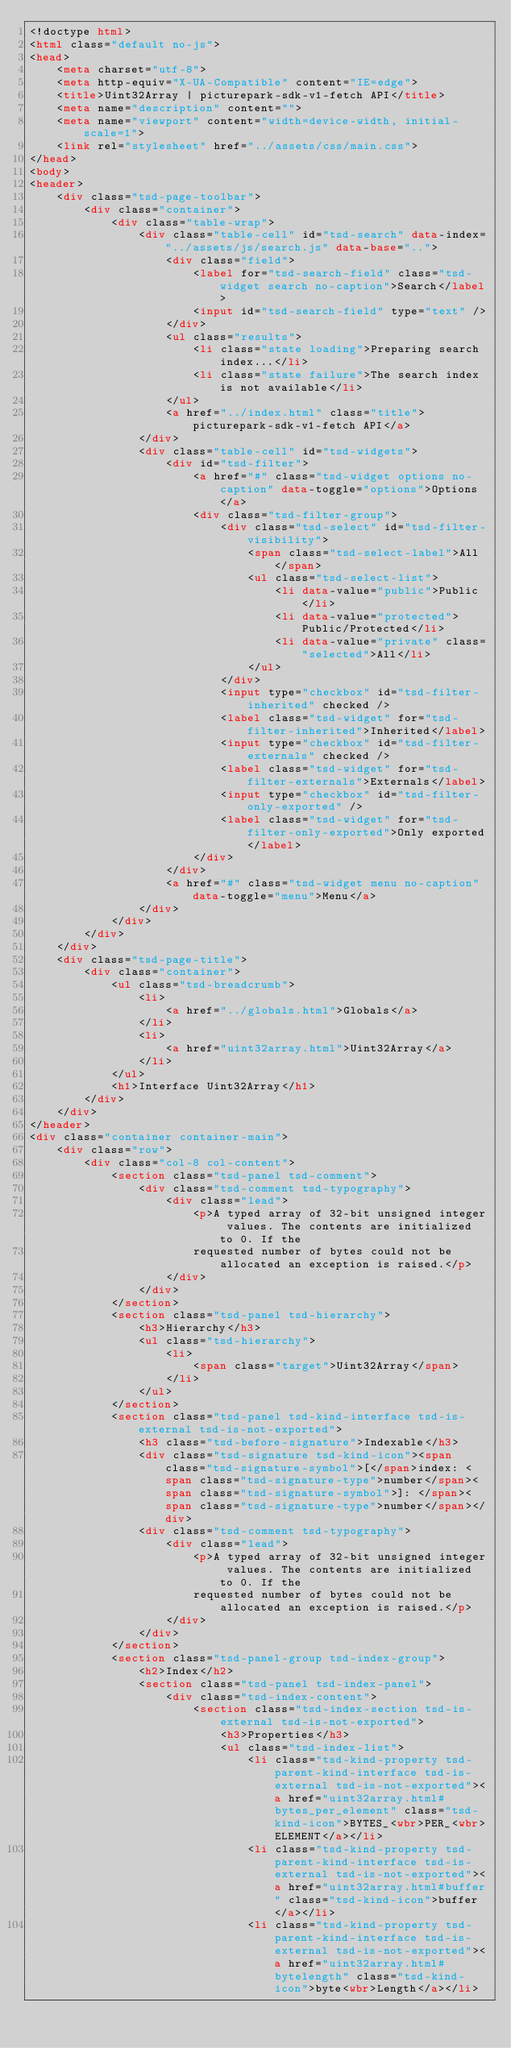Convert code to text. <code><loc_0><loc_0><loc_500><loc_500><_HTML_><!doctype html>
<html class="default no-js">
<head>
	<meta charset="utf-8">
	<meta http-equiv="X-UA-Compatible" content="IE=edge">
	<title>Uint32Array | picturepark-sdk-v1-fetch API</title>
	<meta name="description" content="">
	<meta name="viewport" content="width=device-width, initial-scale=1">
	<link rel="stylesheet" href="../assets/css/main.css">
</head>
<body>
<header>
	<div class="tsd-page-toolbar">
		<div class="container">
			<div class="table-wrap">
				<div class="table-cell" id="tsd-search" data-index="../assets/js/search.js" data-base="..">
					<div class="field">
						<label for="tsd-search-field" class="tsd-widget search no-caption">Search</label>
						<input id="tsd-search-field" type="text" />
					</div>
					<ul class="results">
						<li class="state loading">Preparing search index...</li>
						<li class="state failure">The search index is not available</li>
					</ul>
					<a href="../index.html" class="title">picturepark-sdk-v1-fetch API</a>
				</div>
				<div class="table-cell" id="tsd-widgets">
					<div id="tsd-filter">
						<a href="#" class="tsd-widget options no-caption" data-toggle="options">Options</a>
						<div class="tsd-filter-group">
							<div class="tsd-select" id="tsd-filter-visibility">
								<span class="tsd-select-label">All</span>
								<ul class="tsd-select-list">
									<li data-value="public">Public</li>
									<li data-value="protected">Public/Protected</li>
									<li data-value="private" class="selected">All</li>
								</ul>
							</div>
							<input type="checkbox" id="tsd-filter-inherited" checked />
							<label class="tsd-widget" for="tsd-filter-inherited">Inherited</label>
							<input type="checkbox" id="tsd-filter-externals" checked />
							<label class="tsd-widget" for="tsd-filter-externals">Externals</label>
							<input type="checkbox" id="tsd-filter-only-exported" />
							<label class="tsd-widget" for="tsd-filter-only-exported">Only exported</label>
						</div>
					</div>
					<a href="#" class="tsd-widget menu no-caption" data-toggle="menu">Menu</a>
				</div>
			</div>
		</div>
	</div>
	<div class="tsd-page-title">
		<div class="container">
			<ul class="tsd-breadcrumb">
				<li>
					<a href="../globals.html">Globals</a>
				</li>
				<li>
					<a href="uint32array.html">Uint32Array</a>
				</li>
			</ul>
			<h1>Interface Uint32Array</h1>
		</div>
	</div>
</header>
<div class="container container-main">
	<div class="row">
		<div class="col-8 col-content">
			<section class="tsd-panel tsd-comment">
				<div class="tsd-comment tsd-typography">
					<div class="lead">
						<p>A typed array of 32-bit unsigned integer values. The contents are initialized to 0. If the
						requested number of bytes could not be allocated an exception is raised.</p>
					</div>
				</div>
			</section>
			<section class="tsd-panel tsd-hierarchy">
				<h3>Hierarchy</h3>
				<ul class="tsd-hierarchy">
					<li>
						<span class="target">Uint32Array</span>
					</li>
				</ul>
			</section>
			<section class="tsd-panel tsd-kind-interface tsd-is-external tsd-is-not-exported">
				<h3 class="tsd-before-signature">Indexable</h3>
				<div class="tsd-signature tsd-kind-icon"><span class="tsd-signature-symbol">[</span>index: <span class="tsd-signature-type">number</span><span class="tsd-signature-symbol">]: </span><span class="tsd-signature-type">number</span></div>
				<div class="tsd-comment tsd-typography">
					<div class="lead">
						<p>A typed array of 32-bit unsigned integer values. The contents are initialized to 0. If the
						requested number of bytes could not be allocated an exception is raised.</p>
					</div>
				</div>
			</section>
			<section class="tsd-panel-group tsd-index-group">
				<h2>Index</h2>
				<section class="tsd-panel tsd-index-panel">
					<div class="tsd-index-content">
						<section class="tsd-index-section tsd-is-external tsd-is-not-exported">
							<h3>Properties</h3>
							<ul class="tsd-index-list">
								<li class="tsd-kind-property tsd-parent-kind-interface tsd-is-external tsd-is-not-exported"><a href="uint32array.html#bytes_per_element" class="tsd-kind-icon">BYTES_<wbr>PER_<wbr>ELEMENT</a></li>
								<li class="tsd-kind-property tsd-parent-kind-interface tsd-is-external tsd-is-not-exported"><a href="uint32array.html#buffer" class="tsd-kind-icon">buffer</a></li>
								<li class="tsd-kind-property tsd-parent-kind-interface tsd-is-external tsd-is-not-exported"><a href="uint32array.html#bytelength" class="tsd-kind-icon">byte<wbr>Length</a></li></code> 